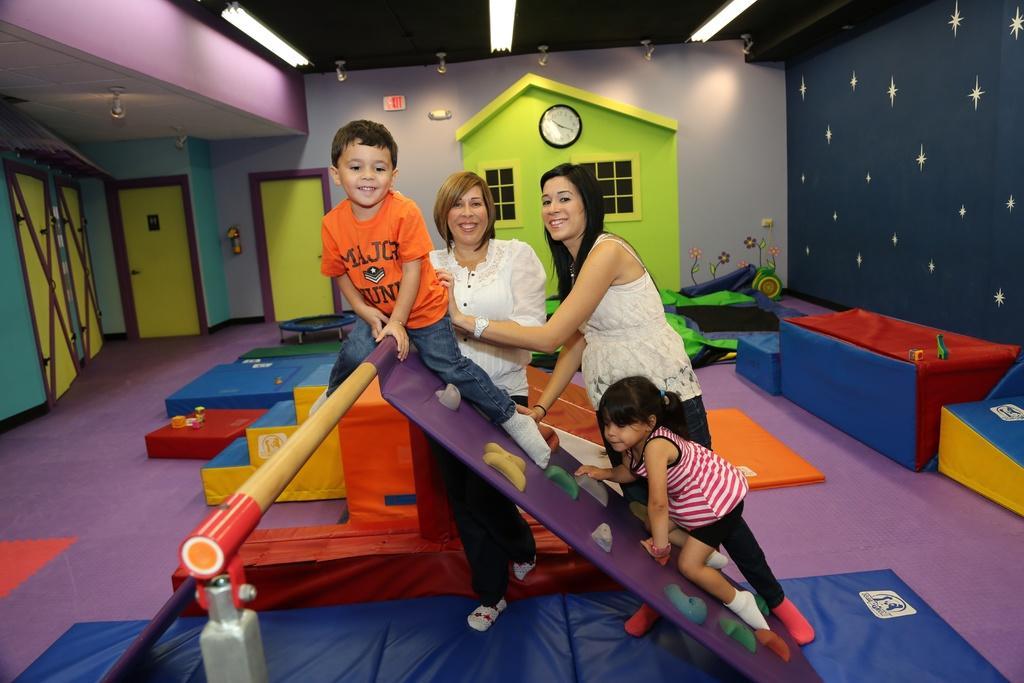In one or two sentences, can you explain what this image depicts? In the image there are two kids and two women standing in a kids play room with colorful walls and door in the back and lights over the ceiling. 